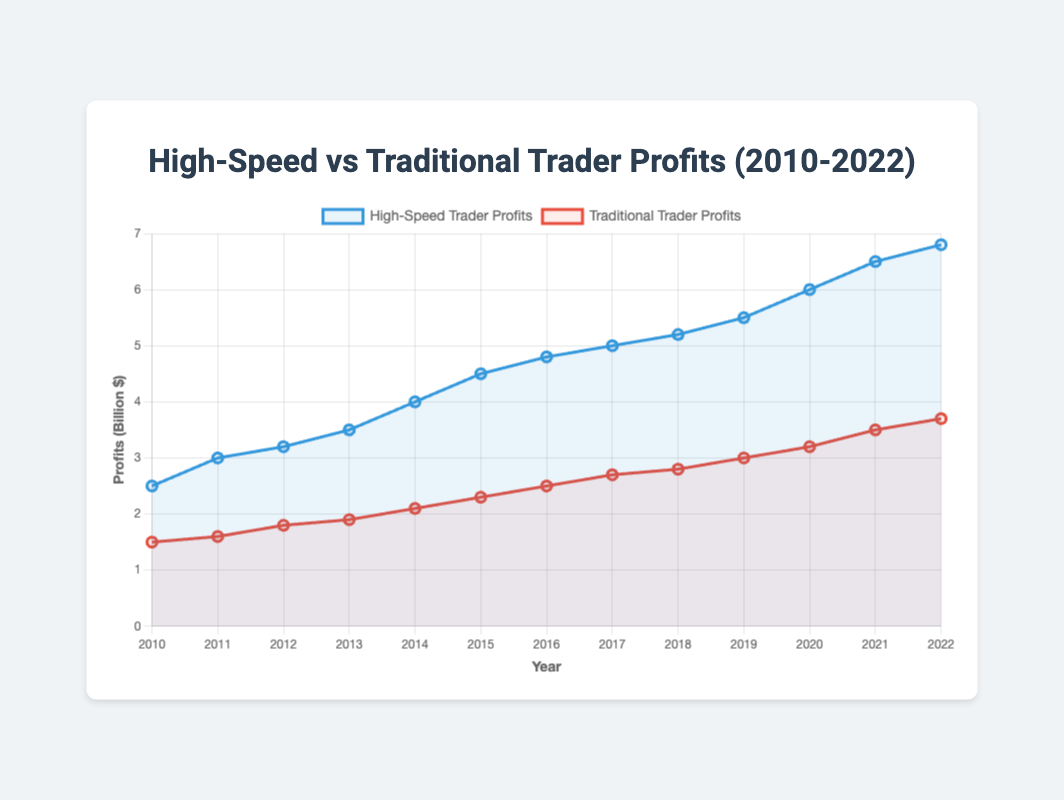What year did high-speed trader profits first exceed $6 billion? We observe that the blue line (high-speed trader profits) crosses the $6 billion mark in 2020.
Answer: 2020 What's the difference in profits between high-speed and traditional traders in 2022? In 2022, high-speed trader profits are $6.8 billion, and traditional trader profits are $3.7 billion. The difference is calculated as $6.8 billion - $3.7 billion.
Answer: $3.1 billion How did the growth rate of high-speed trader profits compare to traditional trader profits from 2010 to 2015? In 2010, high-speed trader profits were $2.5 billion and grew to $4.5 billion in 2015, an increase of $2.0 billion. Traditional trader profits grew from $1.5 billion to $2.3 billion, an increase of $0.8 billion. High-speed trader profits grew by a larger amount.
Answer: High-speed trader profits grew faster Which color line represents traditional trader profits? From the chart, we can see that the red line corresponds to traditional trader profits.
Answer: Red In what year did both high-speed and traditional trader profits begin to diverge more sharply? By observing the slopes of both lines, the divergence appears to become more pronounced around 2014 when the gradient for high-speed traders noticeably increases.
Answer: 2014 What was the combined total profit of both high-speed and traditional traders in 2017? In 2017, high-speed trader profits were $5.0 billion and traditional trader profits were $2.7 billion. The combined total is $5.0 billion + $2.7 billion.
Answer: $7.7 billion In which year did traditional trader profits first exceed $3 billion? By checking the values along the red line, traditional trader profits first exceed $3 billion in 2019.
Answer: 2019 How much did high-speed trader profits increase from 2011 to 2012? High-speed trader profits were $3.0 billion in 2011 and $3.2 billion in 2012. The increase is calculated as $3.2 billion - $3.0 billion.
Answer: $0.2 billion By how much did the disparity between high-speed and traditional trader profits increase from 2010 to 2020? In 2010, the disparity was $2.5 billion - $1.5 billion = $1.0 billion. In 2020, the disparity was $6.0 billion - $3.2 billion = $2.8 billion. The increase in disparity is $2.8 billion - $1.0 billion.
Answer: $1.8 billion Which year shows the highest profit for high-speed traders? By observing the peak value of the blue line, the highest profit for high-speed traders is in 2022.
Answer: 2022 